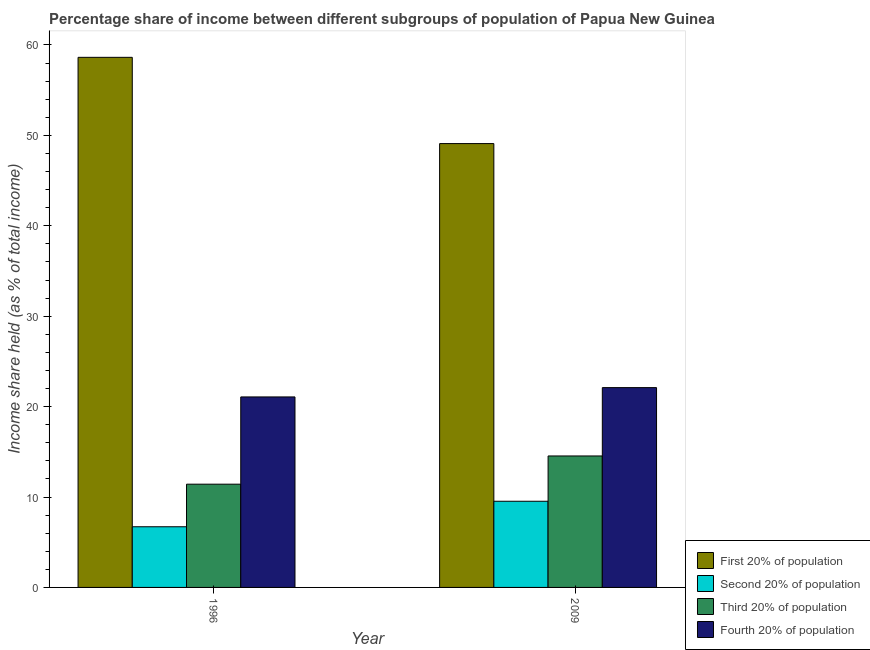How many groups of bars are there?
Ensure brevity in your answer.  2. How many bars are there on the 1st tick from the left?
Your answer should be very brief. 4. How many bars are there on the 2nd tick from the right?
Offer a very short reply. 4. In how many cases, is the number of bars for a given year not equal to the number of legend labels?
Your answer should be compact. 0. What is the share of the income held by second 20% of the population in 1996?
Keep it short and to the point. 6.71. Across all years, what is the maximum share of the income held by third 20% of the population?
Keep it short and to the point. 14.54. Across all years, what is the minimum share of the income held by first 20% of the population?
Make the answer very short. 49.09. In which year was the share of the income held by fourth 20% of the population maximum?
Keep it short and to the point. 2009. In which year was the share of the income held by fourth 20% of the population minimum?
Your answer should be compact. 1996. What is the total share of the income held by fourth 20% of the population in the graph?
Offer a very short reply. 43.17. What is the difference between the share of the income held by fourth 20% of the population in 1996 and that in 2009?
Ensure brevity in your answer.  -1.03. What is the difference between the share of the income held by third 20% of the population in 2009 and the share of the income held by first 20% of the population in 1996?
Ensure brevity in your answer.  3.12. What is the average share of the income held by second 20% of the population per year?
Your answer should be very brief. 8.12. In the year 2009, what is the difference between the share of the income held by second 20% of the population and share of the income held by third 20% of the population?
Your answer should be very brief. 0. What is the ratio of the share of the income held by third 20% of the population in 1996 to that in 2009?
Offer a terse response. 0.79. Is the share of the income held by third 20% of the population in 1996 less than that in 2009?
Your answer should be very brief. Yes. In how many years, is the share of the income held by second 20% of the population greater than the average share of the income held by second 20% of the population taken over all years?
Your answer should be compact. 1. What does the 2nd bar from the left in 2009 represents?
Keep it short and to the point. Second 20% of population. What does the 4th bar from the right in 1996 represents?
Provide a short and direct response. First 20% of population. Is it the case that in every year, the sum of the share of the income held by first 20% of the population and share of the income held by second 20% of the population is greater than the share of the income held by third 20% of the population?
Your answer should be very brief. Yes. How many years are there in the graph?
Your answer should be very brief. 2. What is the difference between two consecutive major ticks on the Y-axis?
Offer a terse response. 10. How many legend labels are there?
Offer a terse response. 4. How are the legend labels stacked?
Offer a terse response. Vertical. What is the title of the graph?
Provide a succinct answer. Percentage share of income between different subgroups of population of Papua New Guinea. What is the label or title of the Y-axis?
Ensure brevity in your answer.  Income share held (as % of total income). What is the Income share held (as % of total income) in First 20% of population in 1996?
Offer a very short reply. 58.63. What is the Income share held (as % of total income) in Second 20% of population in 1996?
Offer a very short reply. 6.71. What is the Income share held (as % of total income) of Third 20% of population in 1996?
Keep it short and to the point. 11.42. What is the Income share held (as % of total income) in Fourth 20% of population in 1996?
Make the answer very short. 21.07. What is the Income share held (as % of total income) in First 20% of population in 2009?
Ensure brevity in your answer.  49.09. What is the Income share held (as % of total income) in Second 20% of population in 2009?
Offer a very short reply. 9.53. What is the Income share held (as % of total income) in Third 20% of population in 2009?
Offer a very short reply. 14.54. What is the Income share held (as % of total income) in Fourth 20% of population in 2009?
Provide a short and direct response. 22.1. Across all years, what is the maximum Income share held (as % of total income) of First 20% of population?
Your response must be concise. 58.63. Across all years, what is the maximum Income share held (as % of total income) of Second 20% of population?
Offer a terse response. 9.53. Across all years, what is the maximum Income share held (as % of total income) in Third 20% of population?
Your answer should be very brief. 14.54. Across all years, what is the maximum Income share held (as % of total income) in Fourth 20% of population?
Offer a very short reply. 22.1. Across all years, what is the minimum Income share held (as % of total income) in First 20% of population?
Make the answer very short. 49.09. Across all years, what is the minimum Income share held (as % of total income) in Second 20% of population?
Ensure brevity in your answer.  6.71. Across all years, what is the minimum Income share held (as % of total income) of Third 20% of population?
Give a very brief answer. 11.42. Across all years, what is the minimum Income share held (as % of total income) of Fourth 20% of population?
Make the answer very short. 21.07. What is the total Income share held (as % of total income) in First 20% of population in the graph?
Give a very brief answer. 107.72. What is the total Income share held (as % of total income) in Second 20% of population in the graph?
Your answer should be very brief. 16.24. What is the total Income share held (as % of total income) in Third 20% of population in the graph?
Your answer should be very brief. 25.96. What is the total Income share held (as % of total income) in Fourth 20% of population in the graph?
Make the answer very short. 43.17. What is the difference between the Income share held (as % of total income) of First 20% of population in 1996 and that in 2009?
Your answer should be very brief. 9.54. What is the difference between the Income share held (as % of total income) of Second 20% of population in 1996 and that in 2009?
Your answer should be compact. -2.82. What is the difference between the Income share held (as % of total income) of Third 20% of population in 1996 and that in 2009?
Give a very brief answer. -3.12. What is the difference between the Income share held (as % of total income) of Fourth 20% of population in 1996 and that in 2009?
Your response must be concise. -1.03. What is the difference between the Income share held (as % of total income) in First 20% of population in 1996 and the Income share held (as % of total income) in Second 20% of population in 2009?
Give a very brief answer. 49.1. What is the difference between the Income share held (as % of total income) of First 20% of population in 1996 and the Income share held (as % of total income) of Third 20% of population in 2009?
Ensure brevity in your answer.  44.09. What is the difference between the Income share held (as % of total income) in First 20% of population in 1996 and the Income share held (as % of total income) in Fourth 20% of population in 2009?
Offer a terse response. 36.53. What is the difference between the Income share held (as % of total income) of Second 20% of population in 1996 and the Income share held (as % of total income) of Third 20% of population in 2009?
Your answer should be compact. -7.83. What is the difference between the Income share held (as % of total income) in Second 20% of population in 1996 and the Income share held (as % of total income) in Fourth 20% of population in 2009?
Your response must be concise. -15.39. What is the difference between the Income share held (as % of total income) in Third 20% of population in 1996 and the Income share held (as % of total income) in Fourth 20% of population in 2009?
Your response must be concise. -10.68. What is the average Income share held (as % of total income) of First 20% of population per year?
Provide a succinct answer. 53.86. What is the average Income share held (as % of total income) in Second 20% of population per year?
Your response must be concise. 8.12. What is the average Income share held (as % of total income) of Third 20% of population per year?
Offer a terse response. 12.98. What is the average Income share held (as % of total income) in Fourth 20% of population per year?
Provide a succinct answer. 21.59. In the year 1996, what is the difference between the Income share held (as % of total income) in First 20% of population and Income share held (as % of total income) in Second 20% of population?
Provide a short and direct response. 51.92. In the year 1996, what is the difference between the Income share held (as % of total income) of First 20% of population and Income share held (as % of total income) of Third 20% of population?
Your answer should be compact. 47.21. In the year 1996, what is the difference between the Income share held (as % of total income) of First 20% of population and Income share held (as % of total income) of Fourth 20% of population?
Provide a succinct answer. 37.56. In the year 1996, what is the difference between the Income share held (as % of total income) of Second 20% of population and Income share held (as % of total income) of Third 20% of population?
Your answer should be very brief. -4.71. In the year 1996, what is the difference between the Income share held (as % of total income) in Second 20% of population and Income share held (as % of total income) in Fourth 20% of population?
Your answer should be very brief. -14.36. In the year 1996, what is the difference between the Income share held (as % of total income) in Third 20% of population and Income share held (as % of total income) in Fourth 20% of population?
Offer a terse response. -9.65. In the year 2009, what is the difference between the Income share held (as % of total income) of First 20% of population and Income share held (as % of total income) of Second 20% of population?
Offer a very short reply. 39.56. In the year 2009, what is the difference between the Income share held (as % of total income) in First 20% of population and Income share held (as % of total income) in Third 20% of population?
Keep it short and to the point. 34.55. In the year 2009, what is the difference between the Income share held (as % of total income) in First 20% of population and Income share held (as % of total income) in Fourth 20% of population?
Make the answer very short. 26.99. In the year 2009, what is the difference between the Income share held (as % of total income) in Second 20% of population and Income share held (as % of total income) in Third 20% of population?
Provide a succinct answer. -5.01. In the year 2009, what is the difference between the Income share held (as % of total income) of Second 20% of population and Income share held (as % of total income) of Fourth 20% of population?
Make the answer very short. -12.57. In the year 2009, what is the difference between the Income share held (as % of total income) in Third 20% of population and Income share held (as % of total income) in Fourth 20% of population?
Your answer should be compact. -7.56. What is the ratio of the Income share held (as % of total income) in First 20% of population in 1996 to that in 2009?
Your answer should be compact. 1.19. What is the ratio of the Income share held (as % of total income) of Second 20% of population in 1996 to that in 2009?
Your answer should be very brief. 0.7. What is the ratio of the Income share held (as % of total income) in Third 20% of population in 1996 to that in 2009?
Your response must be concise. 0.79. What is the ratio of the Income share held (as % of total income) in Fourth 20% of population in 1996 to that in 2009?
Ensure brevity in your answer.  0.95. What is the difference between the highest and the second highest Income share held (as % of total income) of First 20% of population?
Offer a very short reply. 9.54. What is the difference between the highest and the second highest Income share held (as % of total income) of Second 20% of population?
Provide a succinct answer. 2.82. What is the difference between the highest and the second highest Income share held (as % of total income) in Third 20% of population?
Provide a short and direct response. 3.12. What is the difference between the highest and the lowest Income share held (as % of total income) of First 20% of population?
Your answer should be compact. 9.54. What is the difference between the highest and the lowest Income share held (as % of total income) of Second 20% of population?
Keep it short and to the point. 2.82. What is the difference between the highest and the lowest Income share held (as % of total income) of Third 20% of population?
Give a very brief answer. 3.12. 